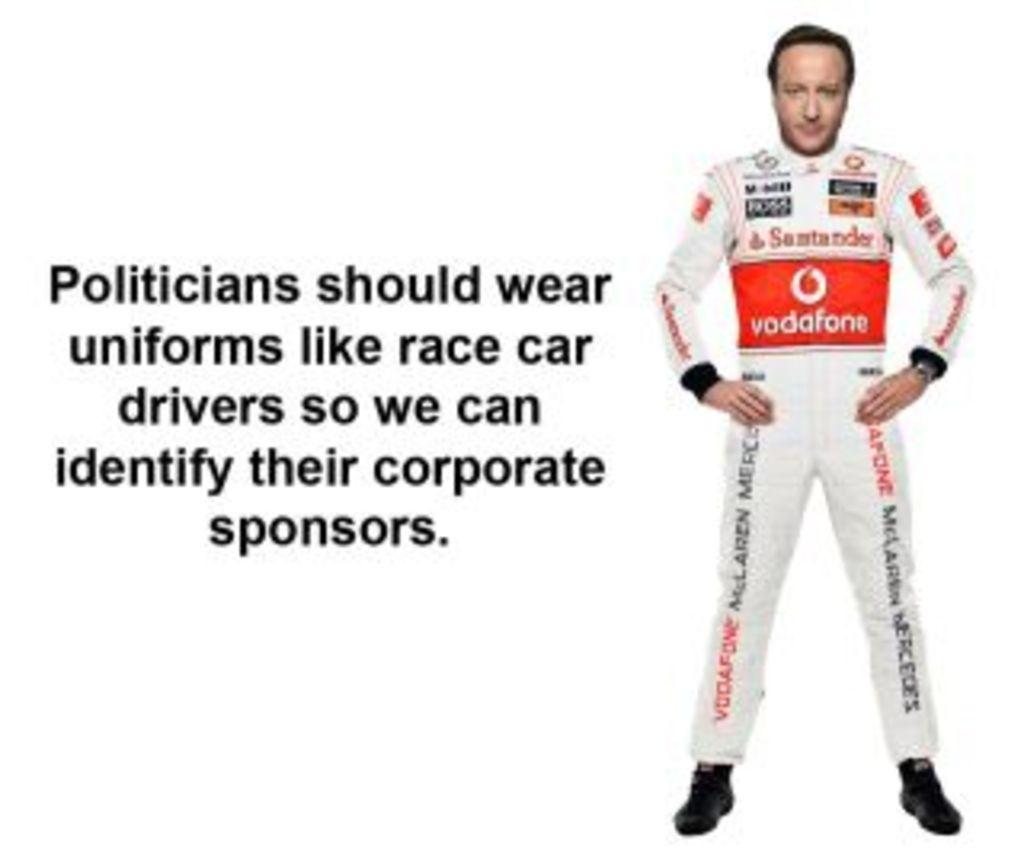<image>
Relay a brief, clear account of the picture shown. An ad suggests politicians dress like Grand Prix racers so we can identify their corporate sponsers. 